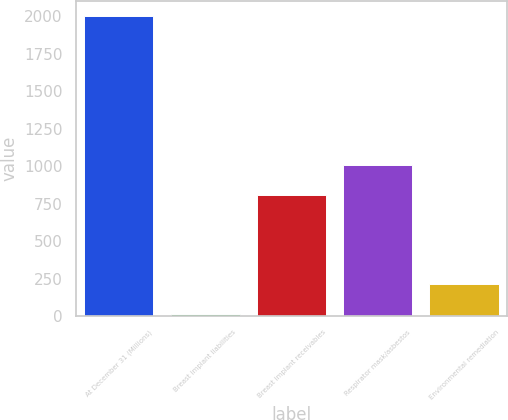<chart> <loc_0><loc_0><loc_500><loc_500><bar_chart><fcel>At December 31 (Millions)<fcel>Breast implant liabilities<fcel>Breast implant receivables<fcel>Respirator mask/asbestos<fcel>Environmental remediation<nl><fcel>2003<fcel>13<fcel>809<fcel>1008<fcel>212<nl></chart> 